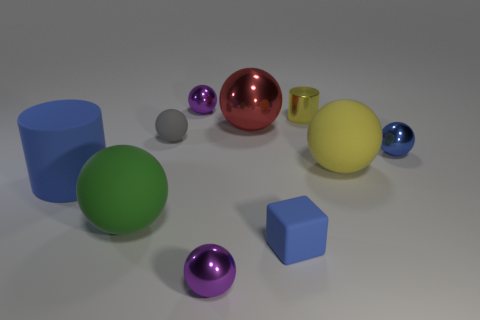Subtract 3 spheres. How many spheres are left? 4 Subtract all green balls. How many balls are left? 6 Subtract all matte spheres. How many spheres are left? 4 Subtract all gray cubes. Subtract all blue balls. How many cubes are left? 1 Subtract all cylinders. How many objects are left? 8 Subtract all large matte things. Subtract all large blue objects. How many objects are left? 6 Add 1 small yellow metal cylinders. How many small yellow metal cylinders are left? 2 Add 6 brown metal cubes. How many brown metal cubes exist? 6 Subtract 0 purple cylinders. How many objects are left? 10 